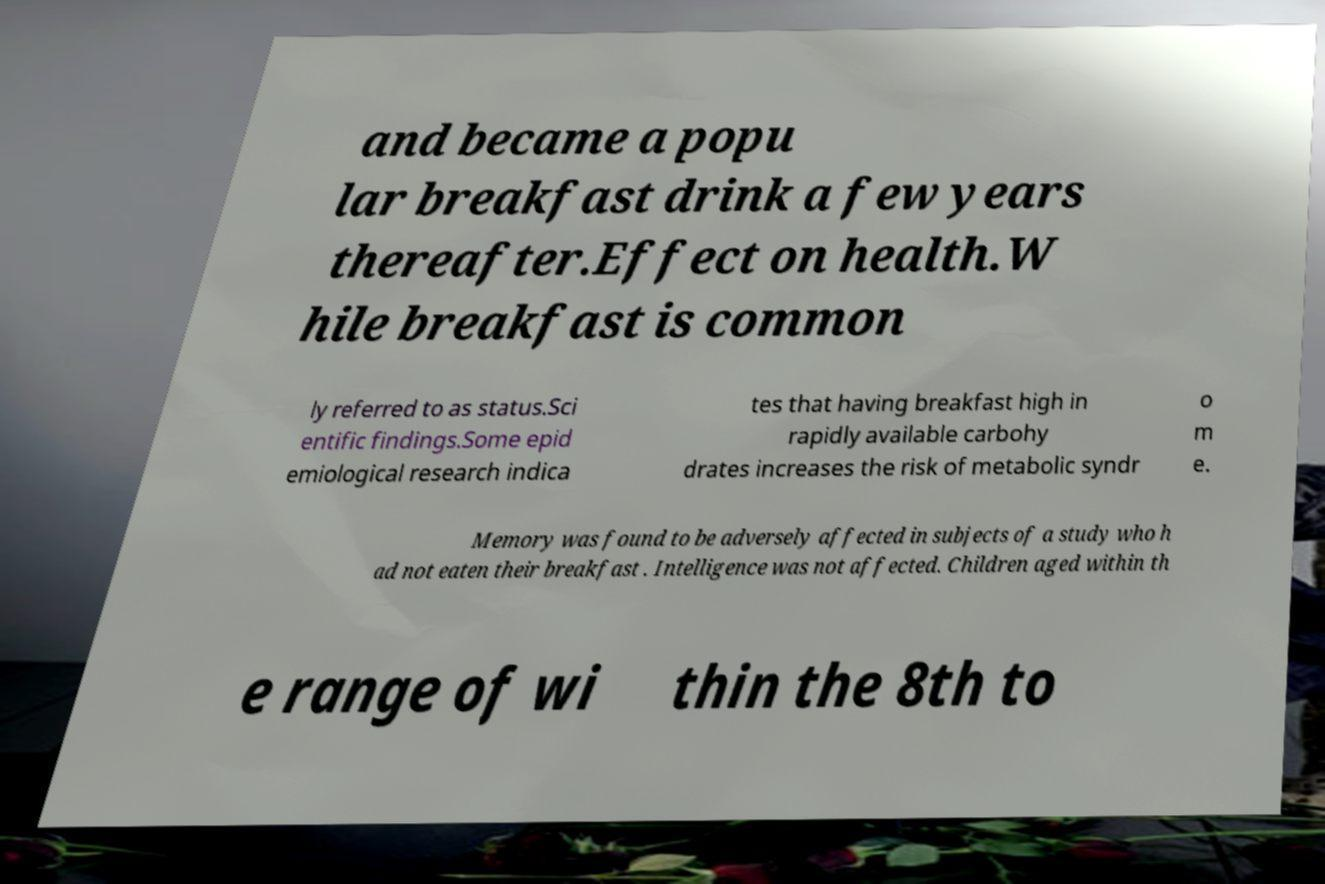There's text embedded in this image that I need extracted. Can you transcribe it verbatim? and became a popu lar breakfast drink a few years thereafter.Effect on health.W hile breakfast is common ly referred to as status.Sci entific findings.Some epid emiological research indica tes that having breakfast high in rapidly available carbohy drates increases the risk of metabolic syndr o m e. Memory was found to be adversely affected in subjects of a study who h ad not eaten their breakfast . Intelligence was not affected. Children aged within th e range of wi thin the 8th to 